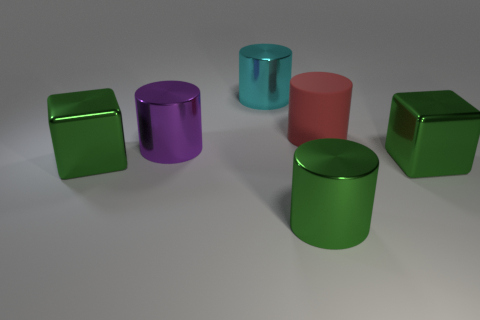What number of large metal objects have the same color as the rubber cylinder?
Your answer should be compact. 0. Is the shape of the large green thing that is to the left of the big cyan metallic cylinder the same as  the large purple metal object?
Keep it short and to the point. No. The object in front of the big cube in front of the big green block left of the green cylinder is what shape?
Provide a succinct answer. Cylinder. How big is the rubber object?
Offer a terse response. Large. What number of large cyan cylinders are the same material as the cyan thing?
Make the answer very short. 0. There is a matte thing; is it the same color as the big cube to the right of the big green shiny cylinder?
Ensure brevity in your answer.  No. There is a large cube right of the green shiny cylinder on the right side of the purple cylinder; what is its color?
Keep it short and to the point. Green. There is a matte cylinder that is the same size as the purple shiny thing; what color is it?
Give a very brief answer. Red. Is there another brown object that has the same shape as the rubber thing?
Your answer should be very brief. No. The rubber thing has what shape?
Keep it short and to the point. Cylinder. 